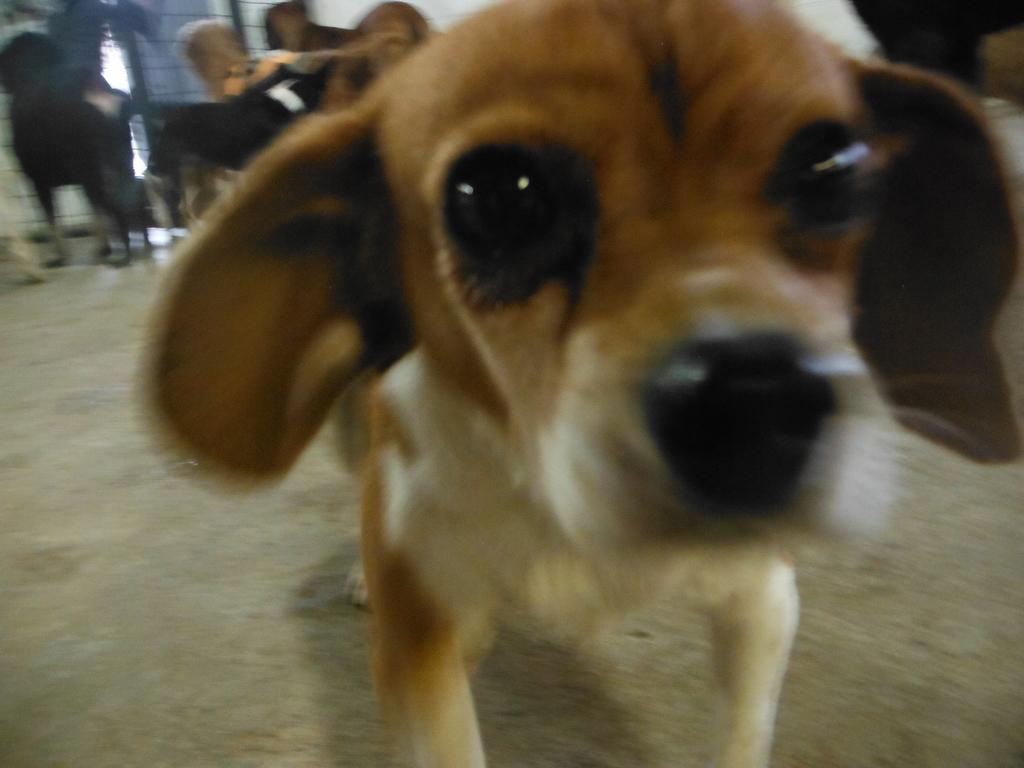What type of animal can be seen in the image? There is a small brown color dog in the image. How is the brown dog positioned in the image? The brown dog is looking into the camera. Are there any other animals in the image? Yes, there is another black dog in the image. What type of structure is visible in the image? There is an iron grill visible in the image. Can you see any tigers playing in the sand in the image? There are no tigers or sand present in the image; it features two dogs and an iron grill. 